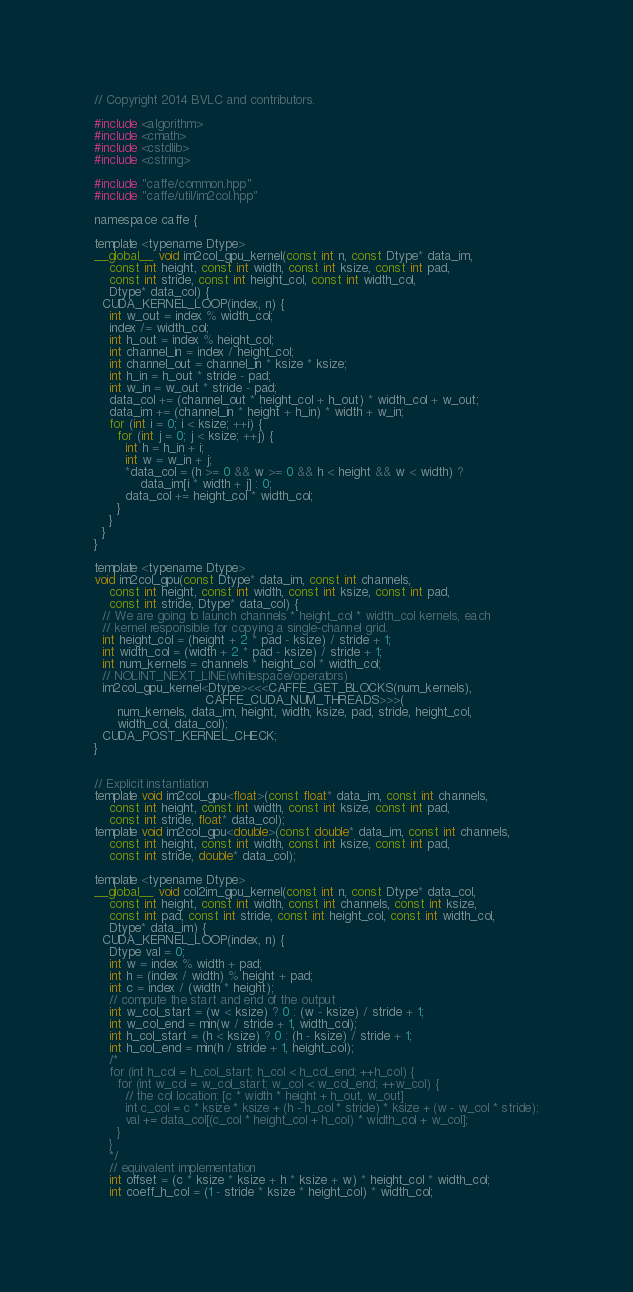<code> <loc_0><loc_0><loc_500><loc_500><_Cuda_>// Copyright 2014 BVLC and contributors.

#include <algorithm>
#include <cmath>
#include <cstdlib>
#include <cstring>

#include "caffe/common.hpp"
#include "caffe/util/im2col.hpp"

namespace caffe {

template <typename Dtype>
__global__ void im2col_gpu_kernel(const int n, const Dtype* data_im,
    const int height, const int width, const int ksize, const int pad,
    const int stride, const int height_col, const int width_col,
    Dtype* data_col) {
  CUDA_KERNEL_LOOP(index, n) {
    int w_out = index % width_col;
    index /= width_col;
    int h_out = index % height_col;
    int channel_in = index / height_col;
    int channel_out = channel_in * ksize * ksize;
    int h_in = h_out * stride - pad;
    int w_in = w_out * stride - pad;
    data_col += (channel_out * height_col + h_out) * width_col + w_out;
    data_im += (channel_in * height + h_in) * width + w_in;
    for (int i = 0; i < ksize; ++i) {
      for (int j = 0; j < ksize; ++j) {
        int h = h_in + i;
        int w = w_in + j;
        *data_col = (h >= 0 && w >= 0 && h < height && w < width) ?
            data_im[i * width + j] : 0;
        data_col += height_col * width_col;
      }
    }
  }
}

template <typename Dtype>
void im2col_gpu(const Dtype* data_im, const int channels,
    const int height, const int width, const int ksize, const int pad,
    const int stride, Dtype* data_col) {
  // We are going to launch channels * height_col * width_col kernels, each
  // kernel responsible for copying a single-channel grid.
  int height_col = (height + 2 * pad - ksize) / stride + 1;
  int width_col = (width + 2 * pad - ksize) / stride + 1;
  int num_kernels = channels * height_col * width_col;
  // NOLINT_NEXT_LINE(whitespace/operators)
  im2col_gpu_kernel<Dtype><<<CAFFE_GET_BLOCKS(num_kernels),
                             CAFFE_CUDA_NUM_THREADS>>>(
      num_kernels, data_im, height, width, ksize, pad, stride, height_col,
      width_col, data_col);
  CUDA_POST_KERNEL_CHECK;
}


// Explicit instantiation
template void im2col_gpu<float>(const float* data_im, const int channels,
    const int height, const int width, const int ksize, const int pad,
    const int stride, float* data_col);
template void im2col_gpu<double>(const double* data_im, const int channels,
    const int height, const int width, const int ksize, const int pad,
    const int stride, double* data_col);

template <typename Dtype>
__global__ void col2im_gpu_kernel(const int n, const Dtype* data_col,
    const int height, const int width, const int channels, const int ksize,
    const int pad, const int stride, const int height_col, const int width_col,
    Dtype* data_im) {
  CUDA_KERNEL_LOOP(index, n) {
    Dtype val = 0;
    int w = index % width + pad;
    int h = (index / width) % height + pad;
    int c = index / (width * height);
    // compute the start and end of the output
    int w_col_start = (w < ksize) ? 0 : (w - ksize) / stride + 1;
    int w_col_end = min(w / stride + 1, width_col);
    int h_col_start = (h < ksize) ? 0 : (h - ksize) / stride + 1;
    int h_col_end = min(h / stride + 1, height_col);
    /*
    for (int h_col = h_col_start; h_col < h_col_end; ++h_col) {
      for (int w_col = w_col_start; w_col < w_col_end; ++w_col) {
        // the col location: [c * width * height + h_out, w_out]
        int c_col = c * ksize * ksize + (h - h_col * stride) * ksize + (w - w_col * stride);
        val += data_col[(c_col * height_col + h_col) * width_col + w_col];
      }
    }
    */
    // equivalent implementation
    int offset = (c * ksize * ksize + h * ksize + w) * height_col * width_col;
    int coeff_h_col = (1 - stride * ksize * height_col) * width_col;</code> 